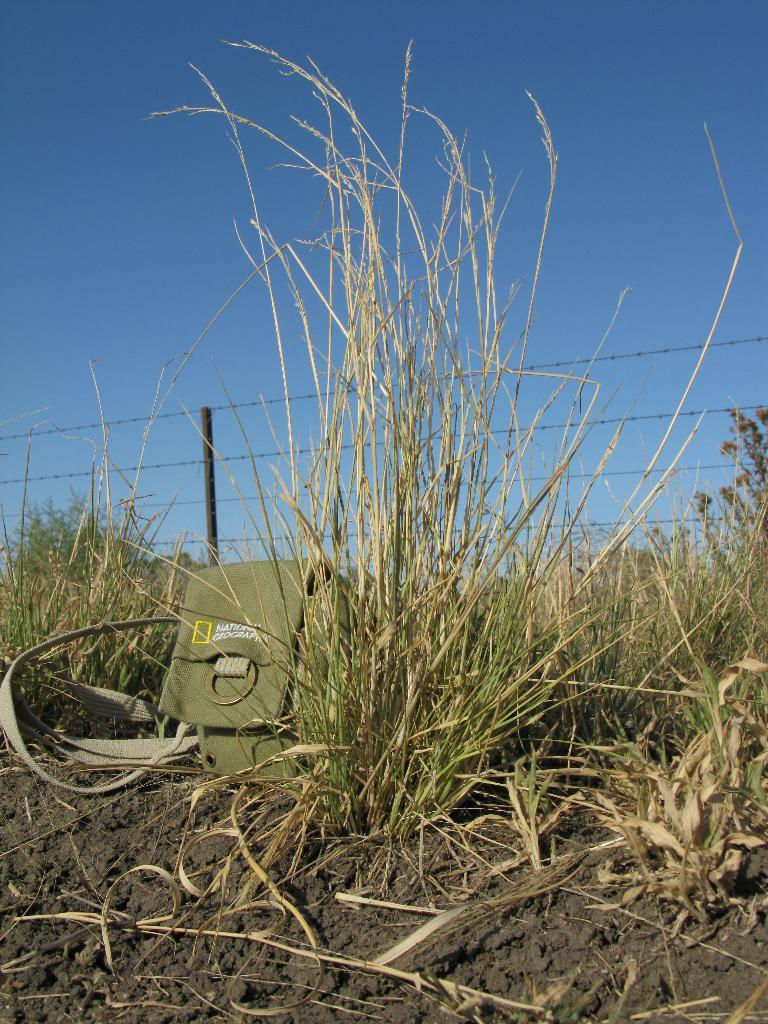What can be seen in the background of the image? There is a clear blue sky and a fence in the background of the image. What type of ground is visible in the image? There is grass visible in the image. What object is placed on the soil in the image? There is a bag on the soil in the image. What language is the beginner learning in the image? There is no indication in the image that anyone is learning a language or that a beginner is present. 